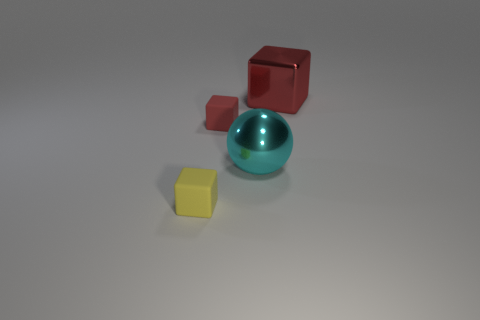Add 3 large cyan cylinders. How many objects exist? 7 Subtract all small yellow matte blocks. How many blocks are left? 2 Subtract all yellow blocks. How many blocks are left? 2 Subtract 1 balls. How many balls are left? 0 Subtract all large cyan objects. Subtract all tiny purple shiny balls. How many objects are left? 3 Add 4 big shiny blocks. How many big shiny blocks are left? 5 Add 4 large balls. How many large balls exist? 5 Subtract 0 green spheres. How many objects are left? 4 Subtract all balls. How many objects are left? 3 Subtract all purple cubes. Subtract all blue balls. How many cubes are left? 3 